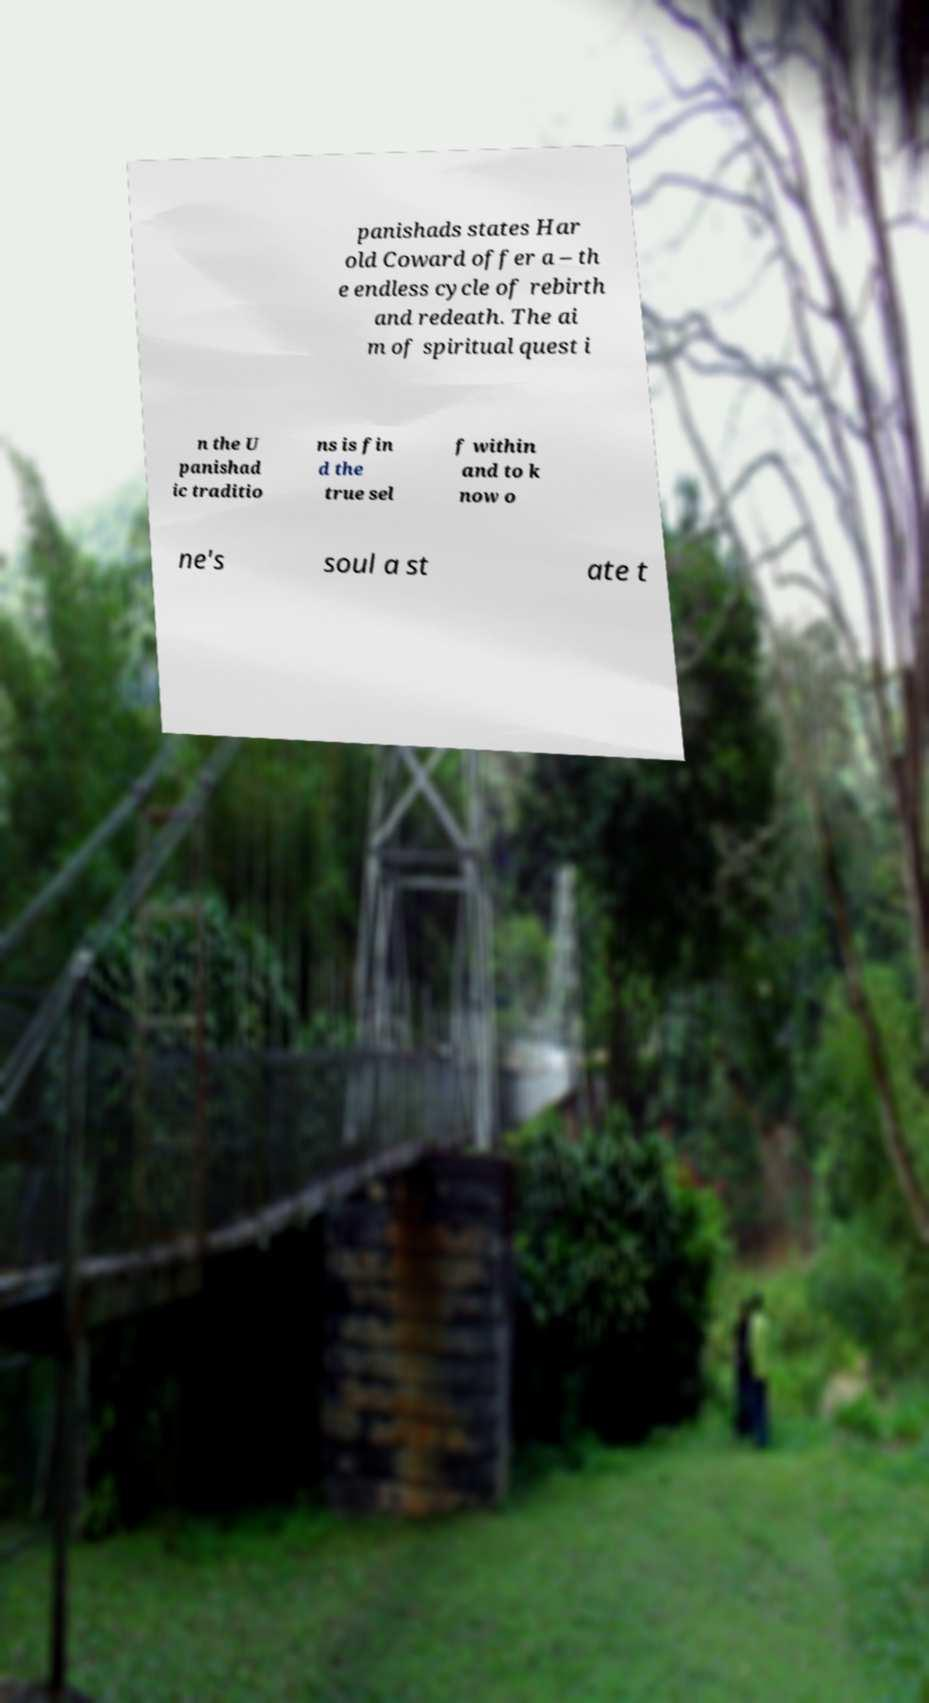Could you assist in decoding the text presented in this image and type it out clearly? panishads states Har old Coward offer a – th e endless cycle of rebirth and redeath. The ai m of spiritual quest i n the U panishad ic traditio ns is fin d the true sel f within and to k now o ne's soul a st ate t 